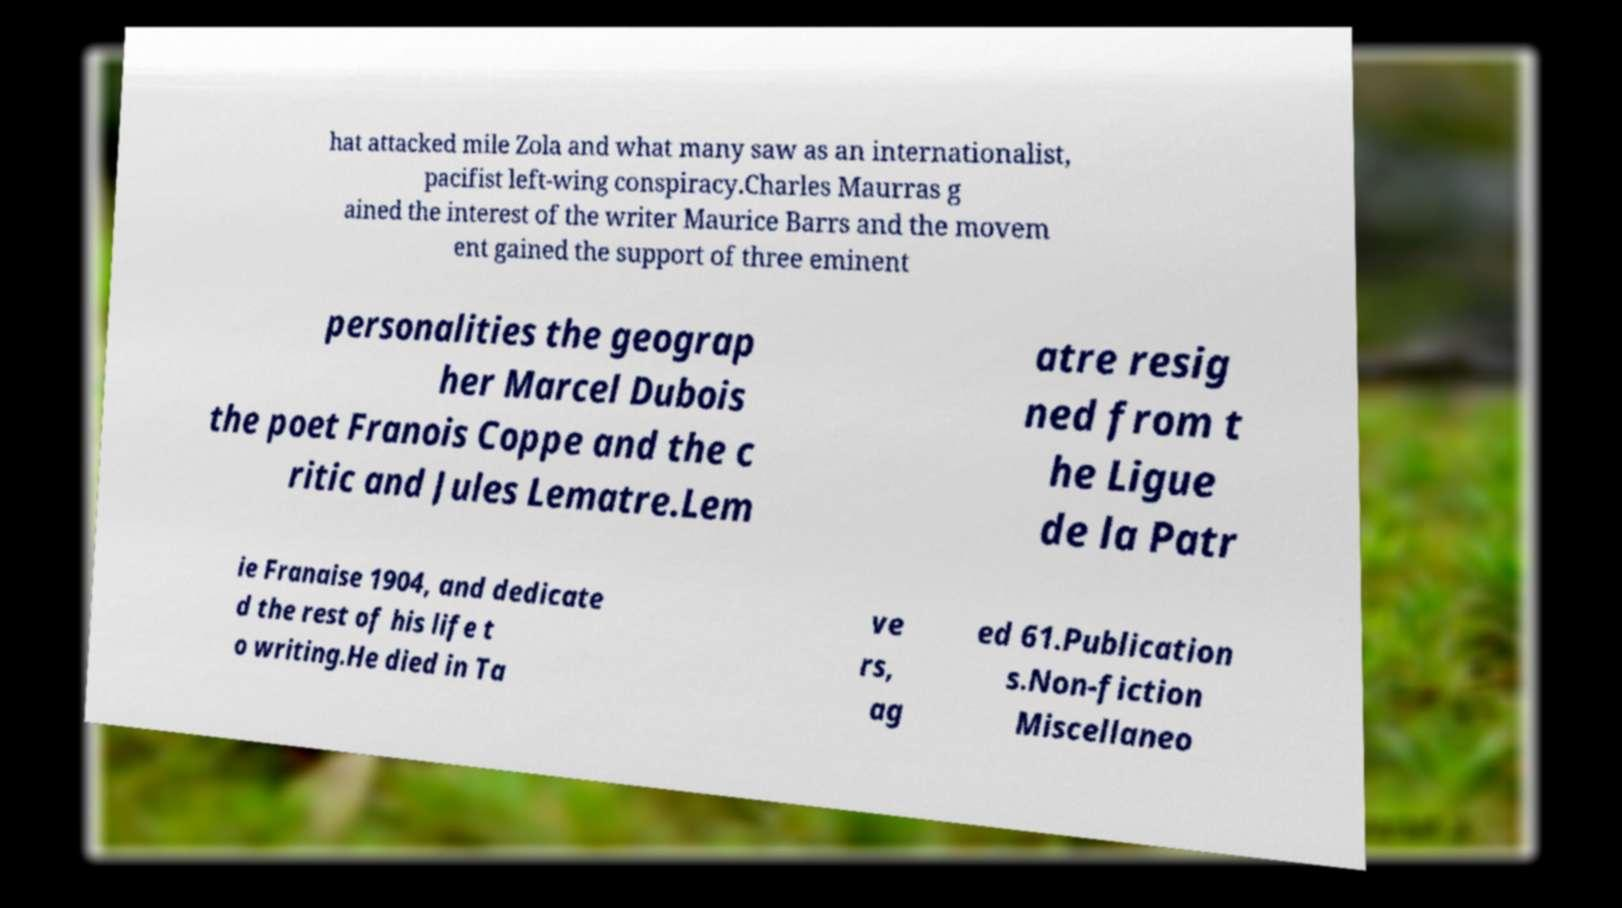Can you accurately transcribe the text from the provided image for me? hat attacked mile Zola and what many saw as an internationalist, pacifist left-wing conspiracy.Charles Maurras g ained the interest of the writer Maurice Barrs and the movem ent gained the support of three eminent personalities the geograp her Marcel Dubois the poet Franois Coppe and the c ritic and Jules Lematre.Lem atre resig ned from t he Ligue de la Patr ie Franaise 1904, and dedicate d the rest of his life t o writing.He died in Ta ve rs, ag ed 61.Publication s.Non-fiction Miscellaneo 